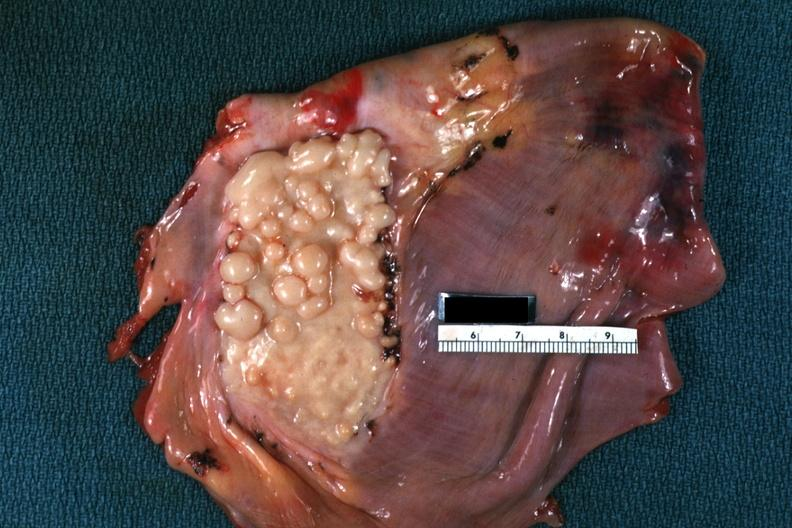what is present?
Answer the question using a single word or phrase. Soft tissue 